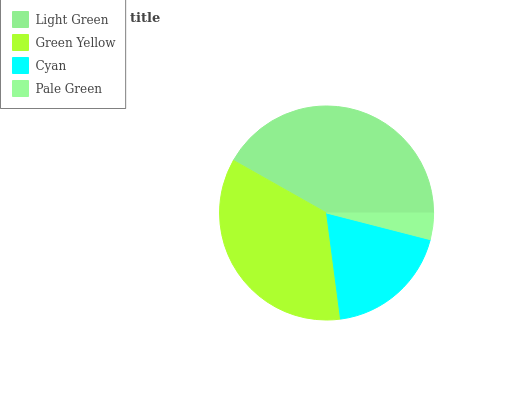Is Pale Green the minimum?
Answer yes or no. Yes. Is Light Green the maximum?
Answer yes or no. Yes. Is Green Yellow the minimum?
Answer yes or no. No. Is Green Yellow the maximum?
Answer yes or no. No. Is Light Green greater than Green Yellow?
Answer yes or no. Yes. Is Green Yellow less than Light Green?
Answer yes or no. Yes. Is Green Yellow greater than Light Green?
Answer yes or no. No. Is Light Green less than Green Yellow?
Answer yes or no. No. Is Green Yellow the high median?
Answer yes or no. Yes. Is Cyan the low median?
Answer yes or no. Yes. Is Light Green the high median?
Answer yes or no. No. Is Green Yellow the low median?
Answer yes or no. No. 